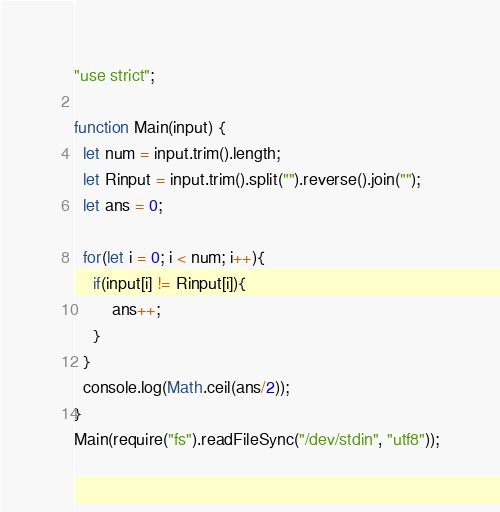Convert code to text. <code><loc_0><loc_0><loc_500><loc_500><_JavaScript_>"use strict";

function Main(input) {
  let num = input.trim().length;
  let Rinput = input.trim().split("").reverse().join("");
  let ans = 0;

  for(let i = 0; i < num; i++){
  	if(input[i] != Rinput[i]){
    	ans++;
    }
  }
  console.log(Math.ceil(ans/2));
}
Main(require("fs").readFileSync("/dev/stdin", "utf8"));
</code> 